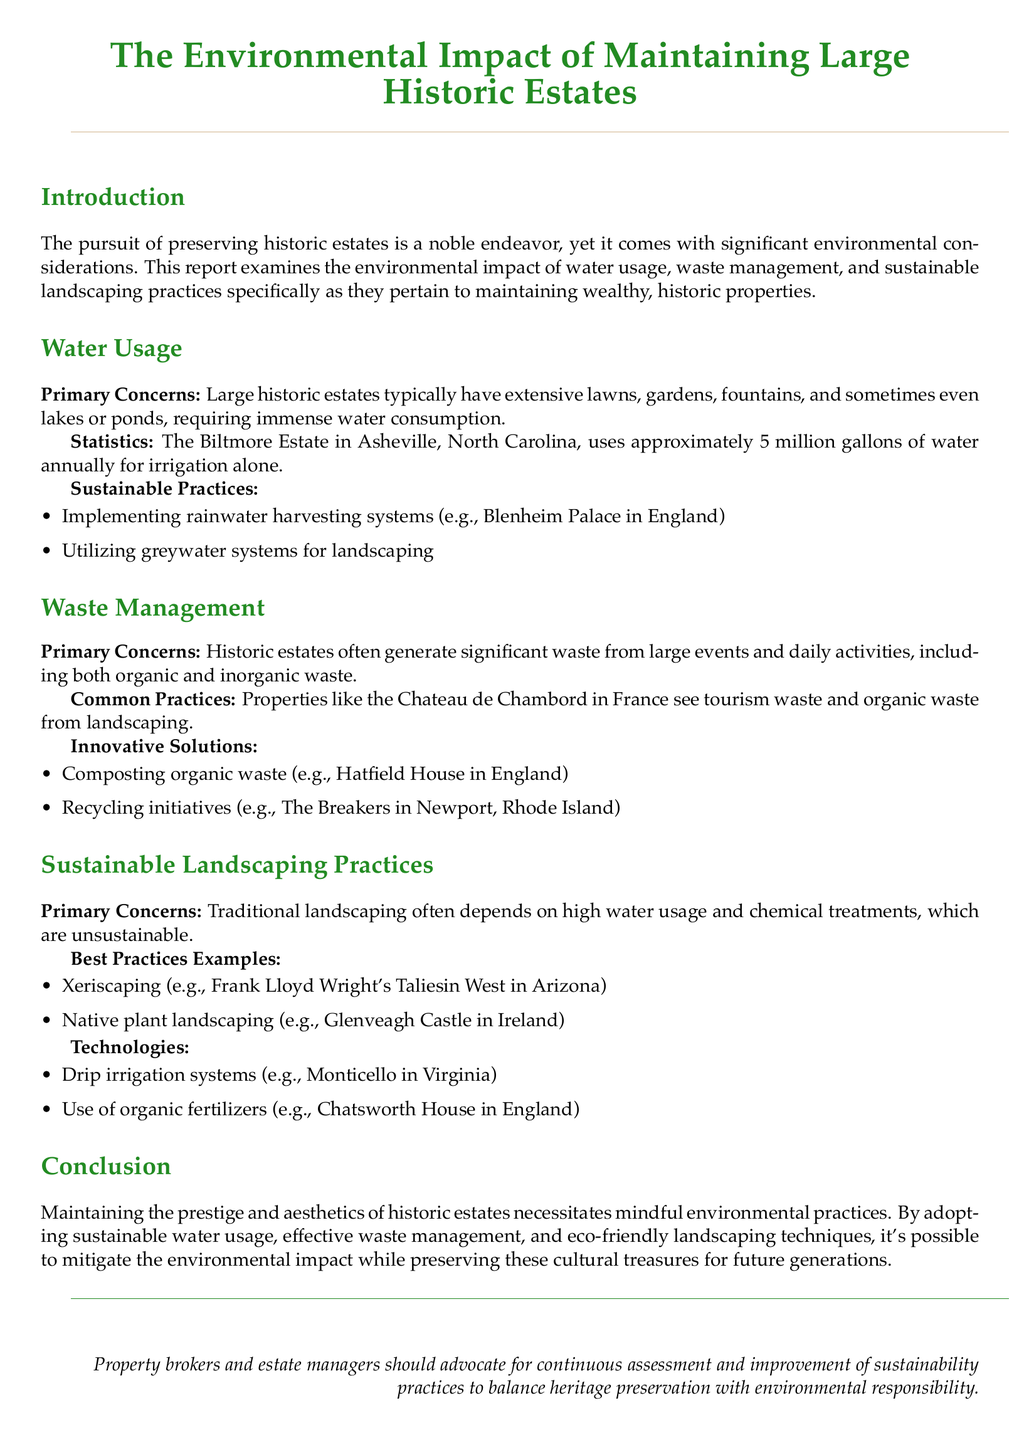what is the water usage at the Biltmore Estate? The Biltmore Estate uses approximately 5 million gallons of water annually for irrigation alone.
Answer: 5 million gallons what is a sustainable practice mentioned for water usage? The report lists rainwater harvesting systems and greywater systems as sustainable practices.
Answer: rainwater harvesting systems what type of waste is generated by historic estates during events? The report indicates that historic estates generate significant waste from both organic and inorganic sources.
Answer: organic and inorganic waste which historic estate practices composting? Hatfield House in England is mentioned as practicing composting of organic waste.
Answer: Hatfield House what landscaping practice avoids high water usage? Xeriscaping is noted as a landscaping practice that avoids high water usage.
Answer: Xeriscaping which estate uses drip irrigation systems? Monticello in Virginia is mentioned as using drip irrigation systems.
Answer: Monticello what does the report advocate for property brokers? The document suggests that property brokers and estate managers should advocate for continuous assessment and improvement of sustainability practices.
Answer: continuous assessment and improvement which historic estate is associated with native plant landscaping? Glenveagh Castle in Ireland is noted for its native plant landscaping.
Answer: Glenveagh Castle what is the primary concern of waste management in historic estates? The report outlines that the primary concern is the significant waste generated from large events and daily activities.
Answer: significant waste from large events and daily activities 